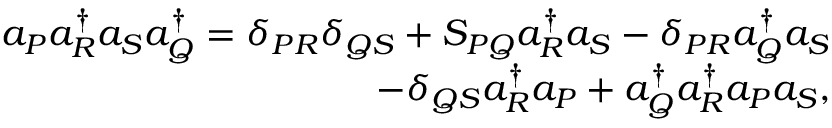<formula> <loc_0><loc_0><loc_500><loc_500>\begin{array} { r } { a _ { P } a _ { R } ^ { \dagger } a _ { S } a _ { Q } ^ { \dagger } = \delta _ { P R } \delta _ { Q S } + S _ { P Q } a _ { R } ^ { \dagger } a _ { S } - \delta _ { P R } a _ { Q } ^ { \dagger } a _ { S } } \\ { - \delta _ { Q S } a _ { R } ^ { \dagger } a _ { P } + a _ { Q } ^ { \dagger } a _ { R } ^ { \dagger } a _ { P } a _ { S } , } \end{array}</formula> 